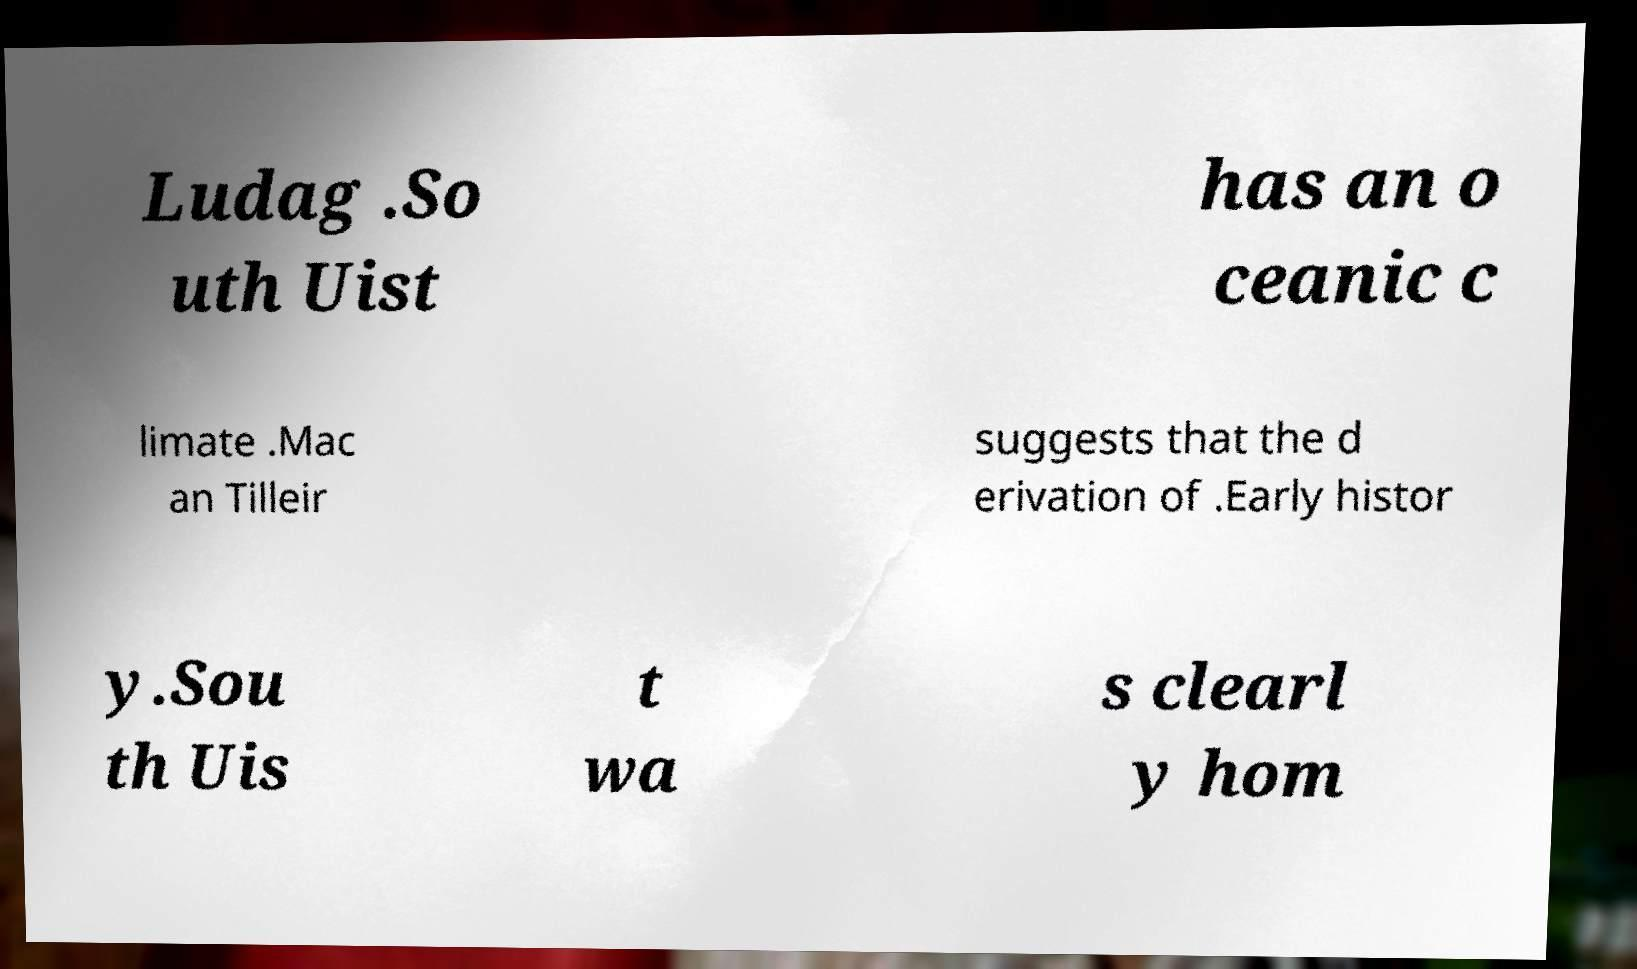Please identify and transcribe the text found in this image. Ludag .So uth Uist has an o ceanic c limate .Mac an Tilleir suggests that the d erivation of .Early histor y.Sou th Uis t wa s clearl y hom 